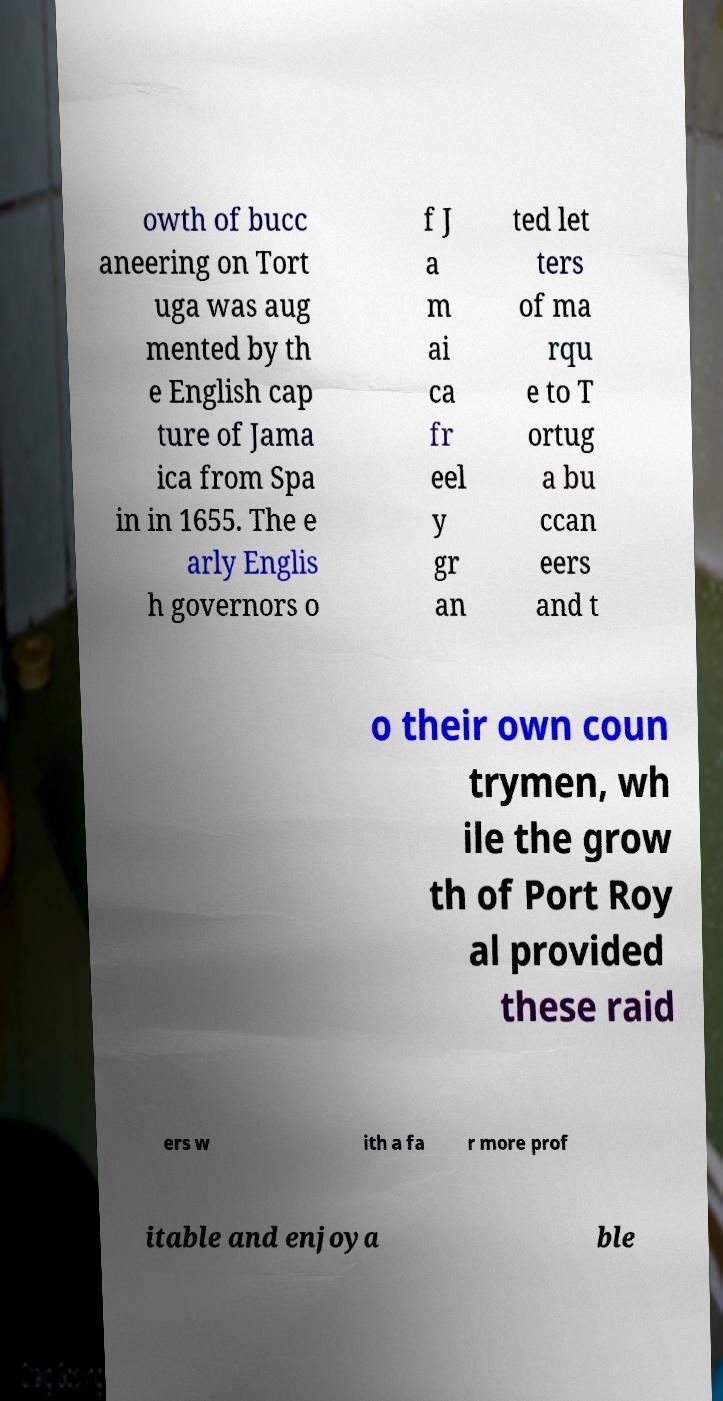For documentation purposes, I need the text within this image transcribed. Could you provide that? owth of bucc aneering on Tort uga was aug mented by th e English cap ture of Jama ica from Spa in in 1655. The e arly Englis h governors o f J a m ai ca fr eel y gr an ted let ters of ma rqu e to T ortug a bu ccan eers and t o their own coun trymen, wh ile the grow th of Port Roy al provided these raid ers w ith a fa r more prof itable and enjoya ble 